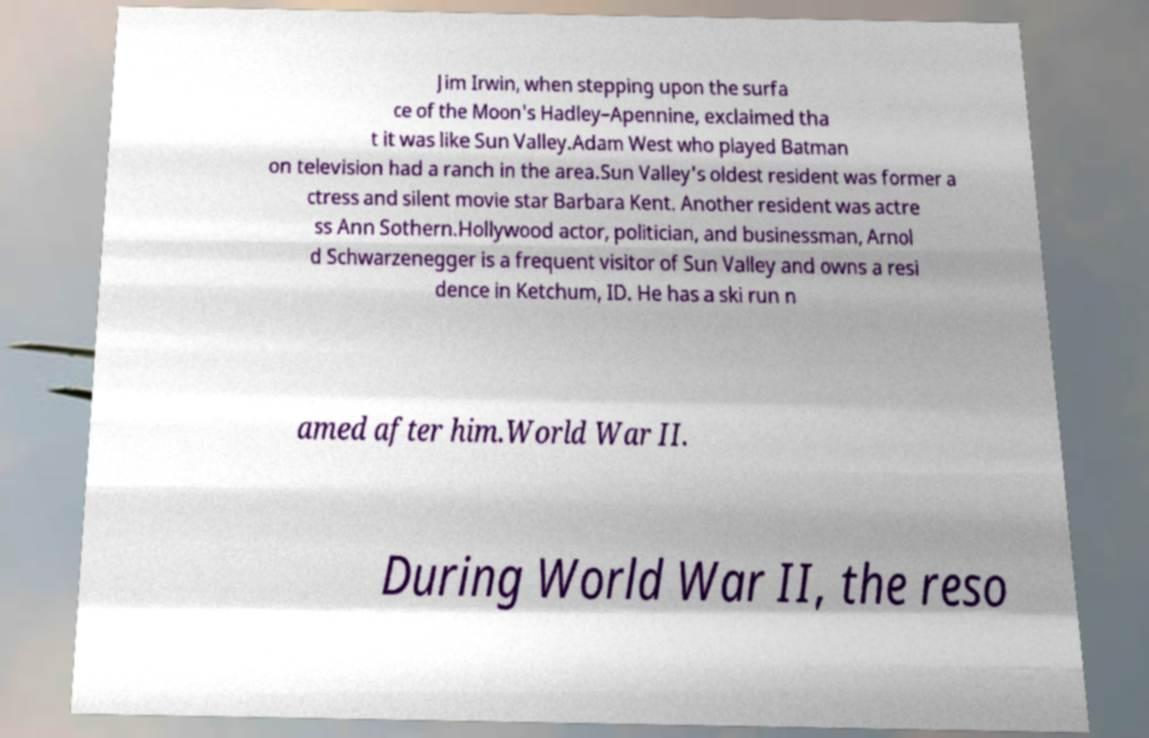Can you read and provide the text displayed in the image?This photo seems to have some interesting text. Can you extract and type it out for me? Jim Irwin, when stepping upon the surfa ce of the Moon's Hadley–Apennine, exclaimed tha t it was like Sun Valley.Adam West who played Batman on television had a ranch in the area.Sun Valley's oldest resident was former a ctress and silent movie star Barbara Kent. Another resident was actre ss Ann Sothern.Hollywood actor, politician, and businessman, Arnol d Schwarzenegger is a frequent visitor of Sun Valley and owns a resi dence in Ketchum, ID. He has a ski run n amed after him.World War II. During World War II, the reso 